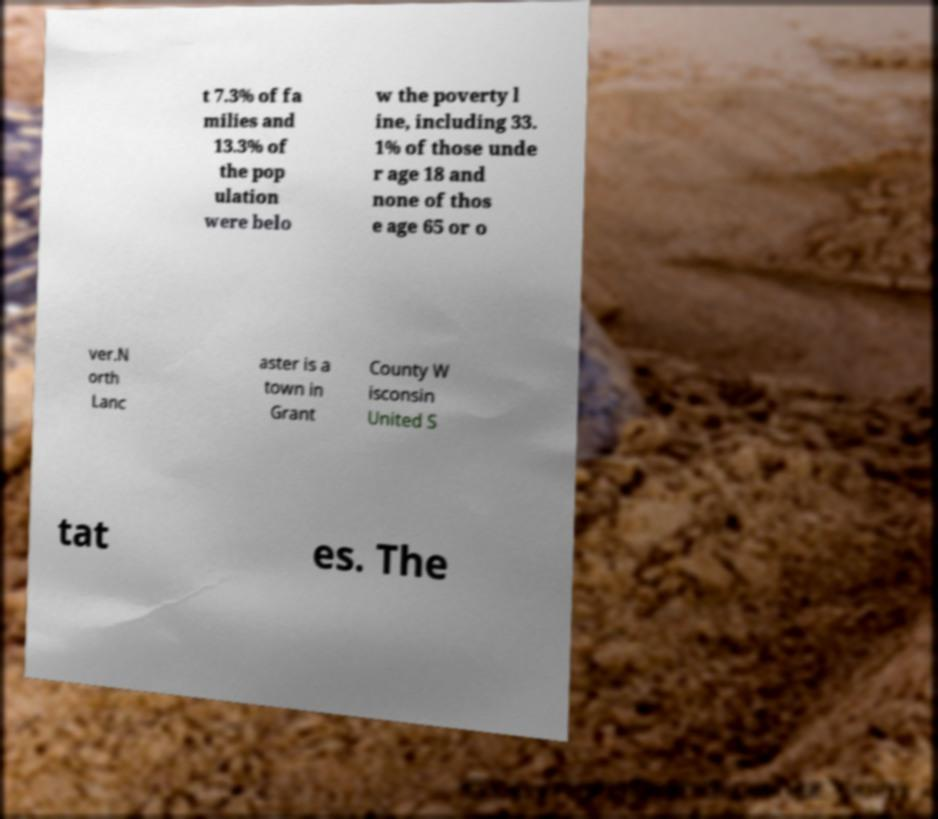Can you read and provide the text displayed in the image?This photo seems to have some interesting text. Can you extract and type it out for me? t 7.3% of fa milies and 13.3% of the pop ulation were belo w the poverty l ine, including 33. 1% of those unde r age 18 and none of thos e age 65 or o ver.N orth Lanc aster is a town in Grant County W isconsin United S tat es. The 